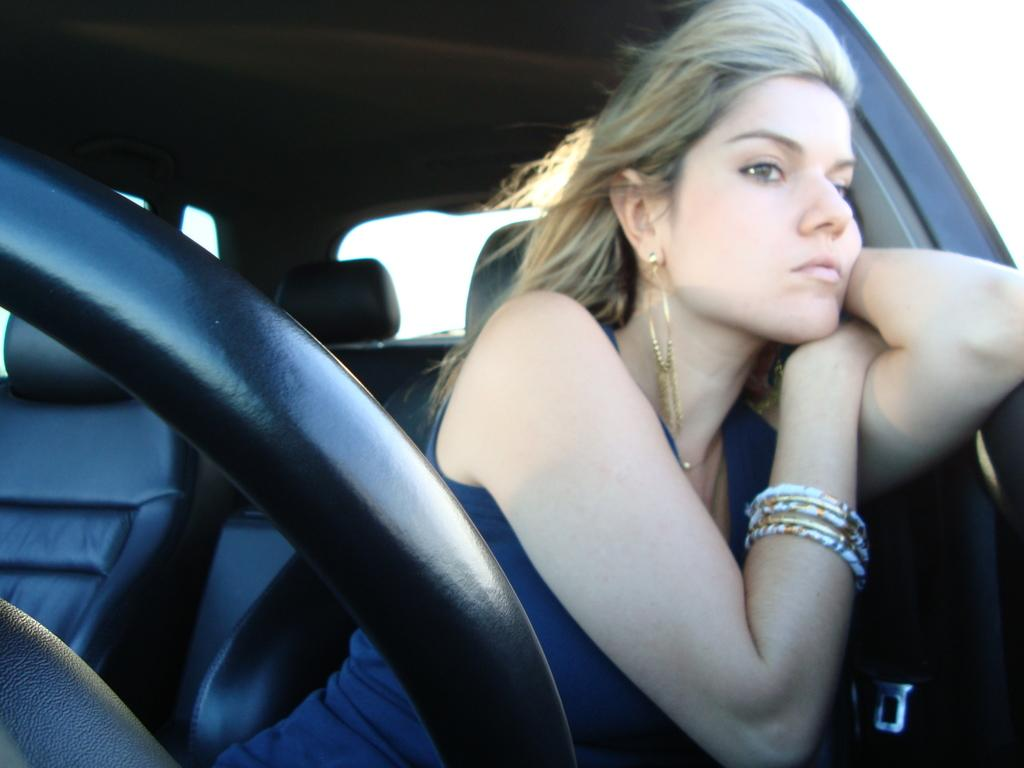Who is present in the image? There is a woman in the image. What is the woman doing in the image? The woman is seated in the image. Where is the woman located in the image? The woman is in a car in the image. What type of plants can be seen growing on the dock in the image? There is no dock or plants present in the image; it features a woman seated in a car. How many balls are visible in the image? There are no balls present in the image. 